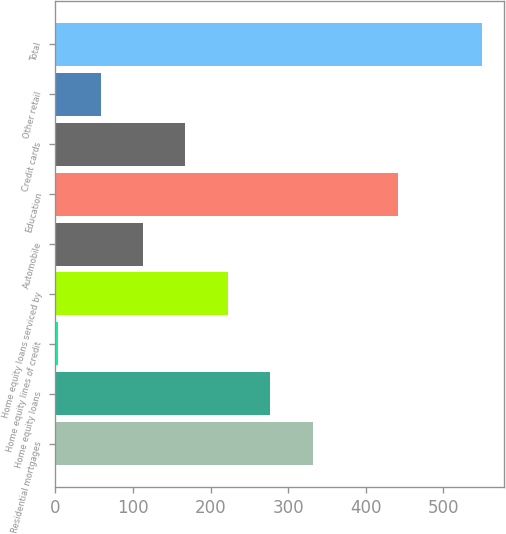Convert chart to OTSL. <chart><loc_0><loc_0><loc_500><loc_500><bar_chart><fcel>Residential mortgages<fcel>Home equity loans<fcel>Home equity lines of credit<fcel>Home equity loans serviced by<fcel>Automobile<fcel>Education<fcel>Credit cards<fcel>Other retail<fcel>Total<nl><fcel>331.6<fcel>277<fcel>4<fcel>222.4<fcel>113.2<fcel>440.8<fcel>167.8<fcel>58.6<fcel>550<nl></chart> 